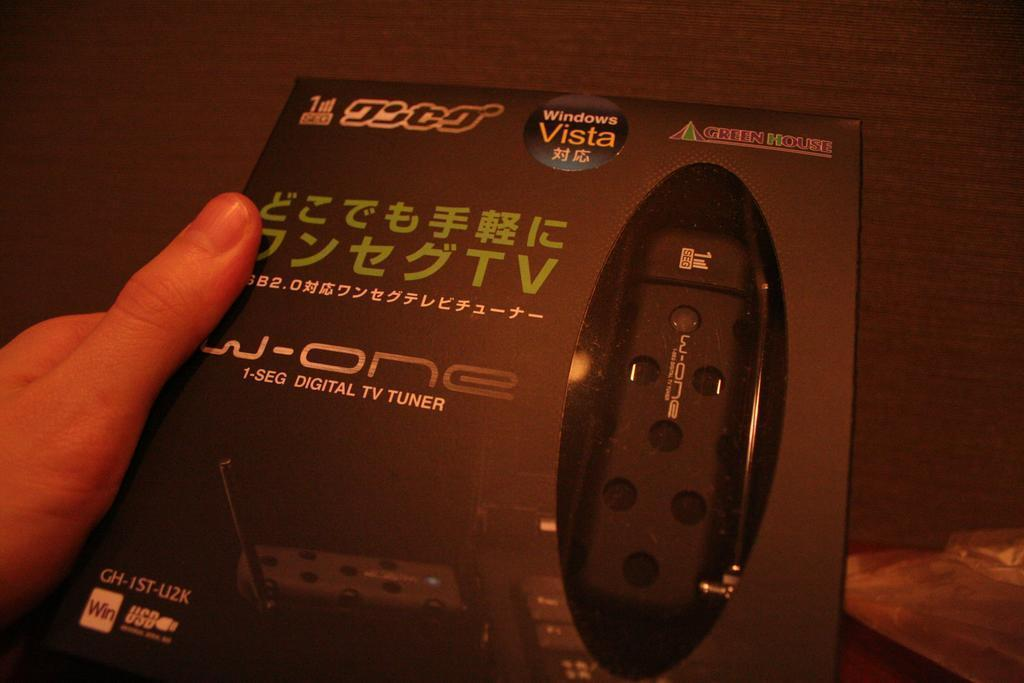What is being held by the person's hand in the image? There is a person's hand holding a box in the image. What can be found inside the box? There is a black color object inside the box. Can you describe the background of the image? There is a cover on a wooden surface in the background of the image. How many kittens are playing with the horses in the image? There are no kittens or horses present in the image. What type of pump is visible on the wooden surface in the background? There is no pump visible on the wooden surface in the background; it is a cover. 